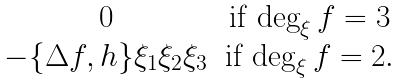Convert formula to latex. <formula><loc_0><loc_0><loc_500><loc_500>\begin{matrix} 0 & \text {if} \, \deg _ { \xi } f = 3 \\ - \{ \Delta f , h \} \xi _ { 1 } \xi _ { 2 } \xi _ { 3 } & \text {if} \, \deg _ { \xi } f = 2 . \end{matrix}</formula> 